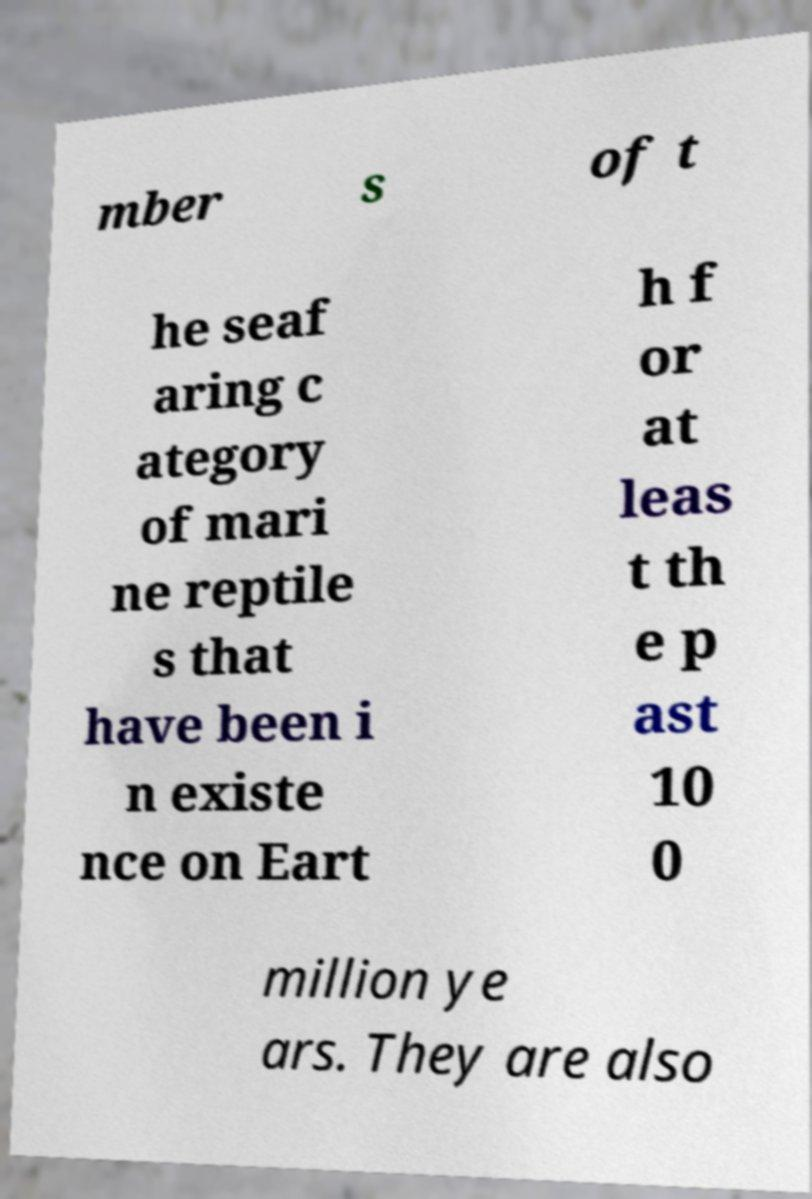What messages or text are displayed in this image? I need them in a readable, typed format. mber s of t he seaf aring c ategory of mari ne reptile s that have been i n existe nce on Eart h f or at leas t th e p ast 10 0 million ye ars. They are also 